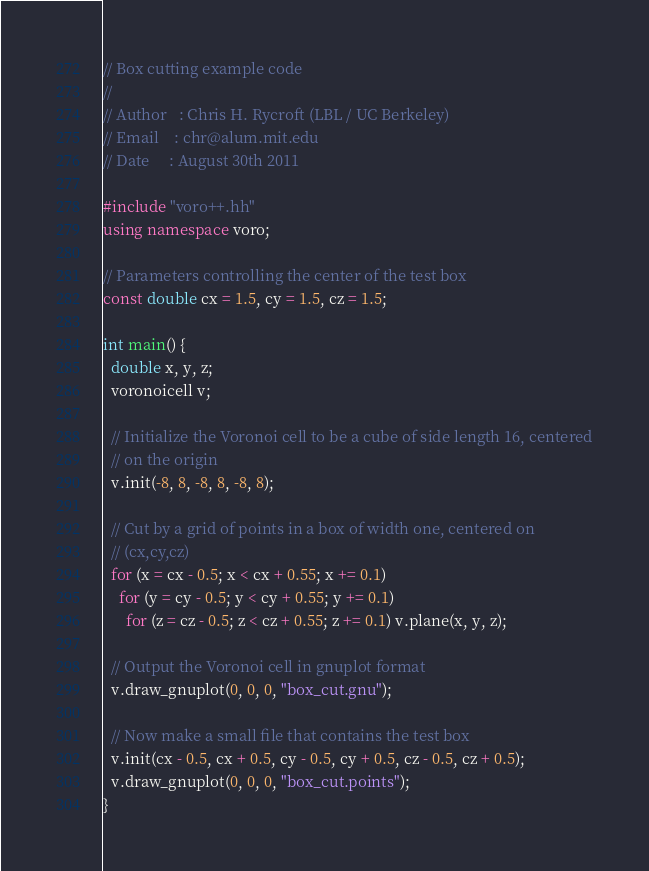<code> <loc_0><loc_0><loc_500><loc_500><_C++_>// Box cutting example code
//
// Author   : Chris H. Rycroft (LBL / UC Berkeley)
// Email    : chr@alum.mit.edu
// Date     : August 30th 2011

#include "voro++.hh"
using namespace voro;

// Parameters controlling the center of the test box
const double cx = 1.5, cy = 1.5, cz = 1.5;

int main() {
  double x, y, z;
  voronoicell v;

  // Initialize the Voronoi cell to be a cube of side length 16, centered
  // on the origin
  v.init(-8, 8, -8, 8, -8, 8);

  // Cut by a grid of points in a box of width one, centered on
  // (cx,cy,cz)
  for (x = cx - 0.5; x < cx + 0.55; x += 0.1)
    for (y = cy - 0.5; y < cy + 0.55; y += 0.1)
      for (z = cz - 0.5; z < cz + 0.55; z += 0.1) v.plane(x, y, z);

  // Output the Voronoi cell in gnuplot format
  v.draw_gnuplot(0, 0, 0, "box_cut.gnu");

  // Now make a small file that contains the test box
  v.init(cx - 0.5, cx + 0.5, cy - 0.5, cy + 0.5, cz - 0.5, cz + 0.5);
  v.draw_gnuplot(0, 0, 0, "box_cut.points");
}
</code> 